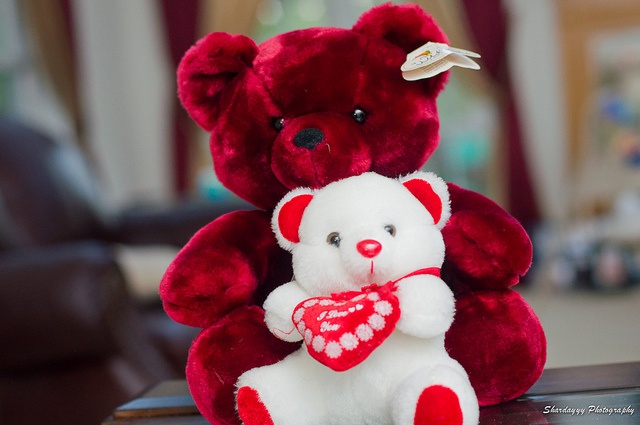Describe the objects in this image and their specific colors. I can see teddy bear in gray, maroon, brown, and black tones, chair in gray and black tones, and teddy bear in gray, lightgray, red, darkgray, and lightpink tones in this image. 